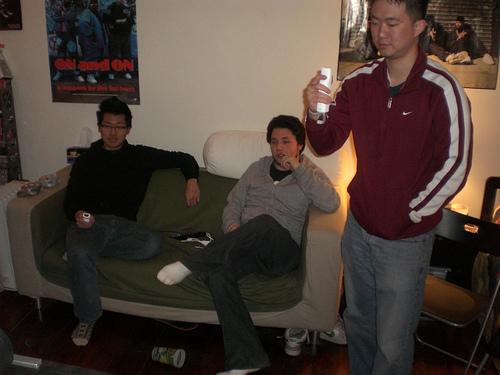Are all the men wearing jeans?
Write a very short answer. Yes. Is the sun out?
Write a very short answer. No. What color are the chairs?
Answer briefly. Black. What is sitting on the floor near the people?
Be succinct. Cup. Are these people in a private area?
Write a very short answer. Yes. What color is the stripe on the man's arm?
Answer briefly. White. What type of pattern is on the man's shirt?
Keep it brief. Stripes. What do the men appear to be looking at?
Write a very short answer. Tv. How many people are in the photo?
Quick response, please. 3. What is the man playing?
Answer briefly. Wii. What are the chairs the people are sitting on, made of?
Be succinct. Cloth. What is in the person's hands?
Give a very brief answer. Remote. What is the man doing?
Short answer required. Playing wii. Are all the men wearing long sleeves?
Quick response, please. Yes. How many people are on skateboards?
Keep it brief. 0. Can you see everyone clearly?
Quick response, please. Yes. 